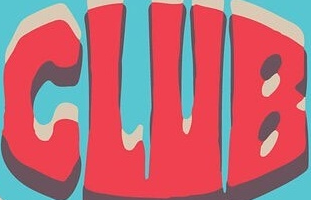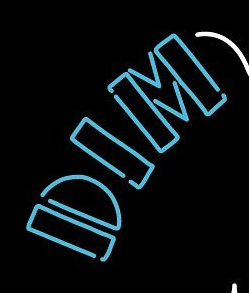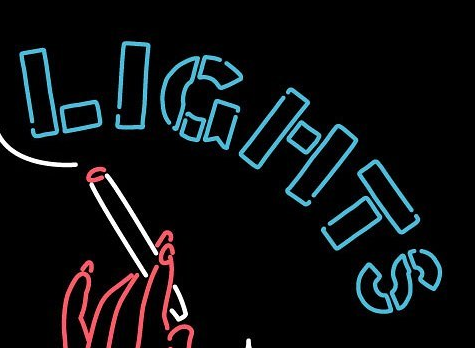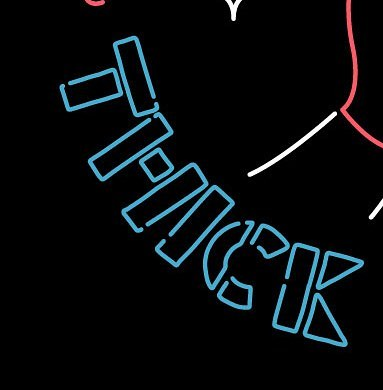Identify the words shown in these images in order, separated by a semicolon. CLUB; DIM; LIGHTS; THICK 